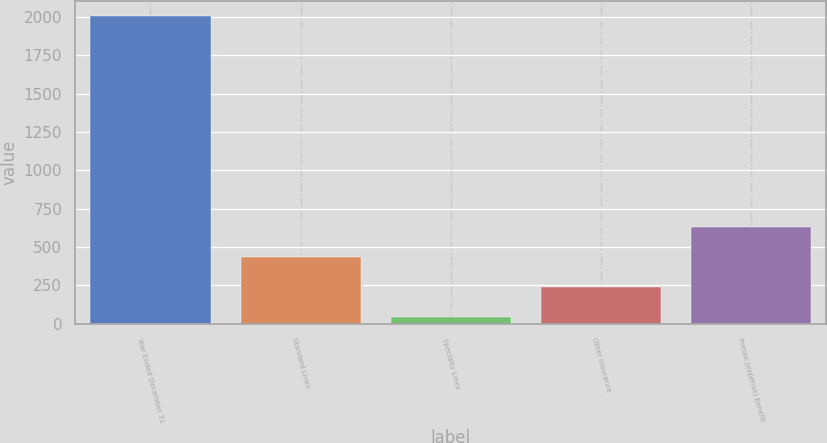Convert chart. <chart><loc_0><loc_0><loc_500><loc_500><bar_chart><fcel>Year Ended December 31<fcel>Standard Lines<fcel>Specialty Lines<fcel>Other Insurance<fcel>Pretax (expense) benefit<nl><fcel>2005<fcel>433.8<fcel>41<fcel>237.4<fcel>630.2<nl></chart> 